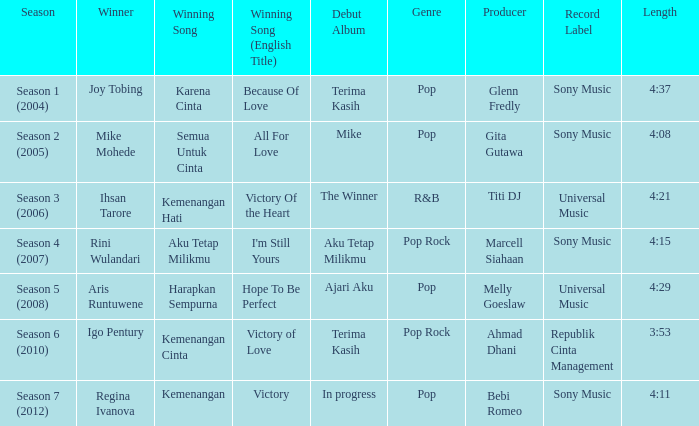Which English winning song had the winner aris runtuwene? Hope To Be Perfect. 